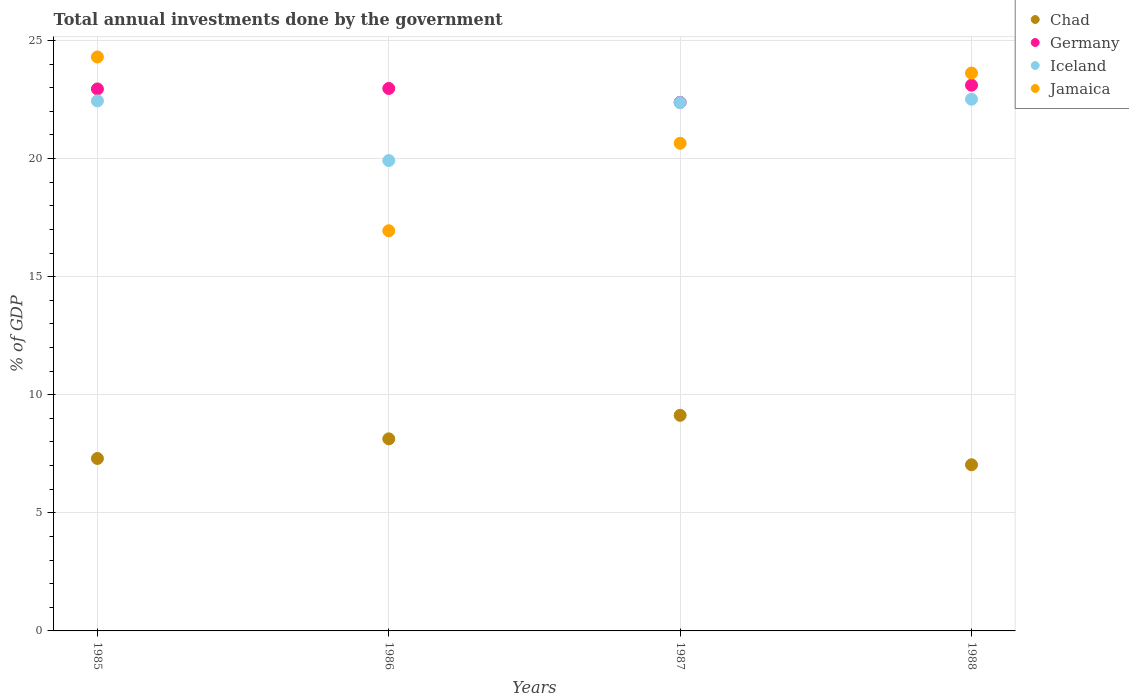What is the total annual investments done by the government in Iceland in 1987?
Your response must be concise. 22.37. Across all years, what is the maximum total annual investments done by the government in Germany?
Provide a short and direct response. 23.11. Across all years, what is the minimum total annual investments done by the government in Jamaica?
Offer a terse response. 16.94. In which year was the total annual investments done by the government in Germany minimum?
Offer a very short reply. 1987. What is the total total annual investments done by the government in Chad in the graph?
Give a very brief answer. 31.6. What is the difference between the total annual investments done by the government in Chad in 1985 and that in 1987?
Make the answer very short. -1.83. What is the difference between the total annual investments done by the government in Germany in 1988 and the total annual investments done by the government in Iceland in 1987?
Provide a short and direct response. 0.74. What is the average total annual investments done by the government in Germany per year?
Ensure brevity in your answer.  22.85. In the year 1985, what is the difference between the total annual investments done by the government in Germany and total annual investments done by the government in Jamaica?
Your answer should be very brief. -1.35. What is the ratio of the total annual investments done by the government in Chad in 1985 to that in 1986?
Your response must be concise. 0.9. What is the difference between the highest and the second highest total annual investments done by the government in Iceland?
Your response must be concise. 0.07. What is the difference between the highest and the lowest total annual investments done by the government in Jamaica?
Your answer should be very brief. 7.36. Is the sum of the total annual investments done by the government in Germany in 1986 and 1987 greater than the maximum total annual investments done by the government in Chad across all years?
Offer a very short reply. Yes. Does the total annual investments done by the government in Jamaica monotonically increase over the years?
Your answer should be compact. No. How many years are there in the graph?
Keep it short and to the point. 4. What is the difference between two consecutive major ticks on the Y-axis?
Provide a short and direct response. 5. Does the graph contain any zero values?
Provide a short and direct response. No. Where does the legend appear in the graph?
Offer a terse response. Top right. How many legend labels are there?
Provide a succinct answer. 4. What is the title of the graph?
Your response must be concise. Total annual investments done by the government. Does "Armenia" appear as one of the legend labels in the graph?
Make the answer very short. No. What is the label or title of the X-axis?
Give a very brief answer. Years. What is the label or title of the Y-axis?
Give a very brief answer. % of GDP. What is the % of GDP of Chad in 1985?
Ensure brevity in your answer.  7.3. What is the % of GDP of Germany in 1985?
Your answer should be compact. 22.95. What is the % of GDP in Iceland in 1985?
Offer a very short reply. 22.44. What is the % of GDP of Jamaica in 1985?
Ensure brevity in your answer.  24.3. What is the % of GDP of Chad in 1986?
Offer a terse response. 8.13. What is the % of GDP in Germany in 1986?
Offer a terse response. 22.97. What is the % of GDP in Iceland in 1986?
Your answer should be compact. 19.92. What is the % of GDP of Jamaica in 1986?
Provide a short and direct response. 16.94. What is the % of GDP of Chad in 1987?
Provide a short and direct response. 9.13. What is the % of GDP in Germany in 1987?
Your answer should be compact. 22.38. What is the % of GDP of Iceland in 1987?
Offer a terse response. 22.37. What is the % of GDP in Jamaica in 1987?
Keep it short and to the point. 20.65. What is the % of GDP in Chad in 1988?
Provide a short and direct response. 7.04. What is the % of GDP in Germany in 1988?
Offer a very short reply. 23.11. What is the % of GDP of Iceland in 1988?
Make the answer very short. 22.52. What is the % of GDP of Jamaica in 1988?
Give a very brief answer. 23.62. Across all years, what is the maximum % of GDP in Chad?
Ensure brevity in your answer.  9.13. Across all years, what is the maximum % of GDP in Germany?
Ensure brevity in your answer.  23.11. Across all years, what is the maximum % of GDP in Iceland?
Provide a short and direct response. 22.52. Across all years, what is the maximum % of GDP in Jamaica?
Offer a terse response. 24.3. Across all years, what is the minimum % of GDP in Chad?
Ensure brevity in your answer.  7.04. Across all years, what is the minimum % of GDP of Germany?
Your response must be concise. 22.38. Across all years, what is the minimum % of GDP of Iceland?
Offer a very short reply. 19.92. Across all years, what is the minimum % of GDP of Jamaica?
Ensure brevity in your answer.  16.94. What is the total % of GDP in Chad in the graph?
Ensure brevity in your answer.  31.6. What is the total % of GDP in Germany in the graph?
Ensure brevity in your answer.  91.41. What is the total % of GDP in Iceland in the graph?
Give a very brief answer. 87.25. What is the total % of GDP in Jamaica in the graph?
Offer a terse response. 85.52. What is the difference between the % of GDP of Chad in 1985 and that in 1986?
Keep it short and to the point. -0.83. What is the difference between the % of GDP in Germany in 1985 and that in 1986?
Your response must be concise. -0.02. What is the difference between the % of GDP in Iceland in 1985 and that in 1986?
Your answer should be compact. 2.53. What is the difference between the % of GDP of Jamaica in 1985 and that in 1986?
Give a very brief answer. 7.36. What is the difference between the % of GDP of Chad in 1985 and that in 1987?
Provide a succinct answer. -1.83. What is the difference between the % of GDP of Germany in 1985 and that in 1987?
Ensure brevity in your answer.  0.57. What is the difference between the % of GDP of Iceland in 1985 and that in 1987?
Give a very brief answer. 0.07. What is the difference between the % of GDP of Jamaica in 1985 and that in 1987?
Provide a succinct answer. 3.65. What is the difference between the % of GDP of Chad in 1985 and that in 1988?
Your answer should be compact. 0.27. What is the difference between the % of GDP of Germany in 1985 and that in 1988?
Make the answer very short. -0.16. What is the difference between the % of GDP of Iceland in 1985 and that in 1988?
Make the answer very short. -0.07. What is the difference between the % of GDP in Jamaica in 1985 and that in 1988?
Make the answer very short. 0.68. What is the difference between the % of GDP in Chad in 1986 and that in 1987?
Keep it short and to the point. -1. What is the difference between the % of GDP in Germany in 1986 and that in 1987?
Your answer should be compact. 0.59. What is the difference between the % of GDP in Iceland in 1986 and that in 1987?
Offer a very short reply. -2.46. What is the difference between the % of GDP in Jamaica in 1986 and that in 1987?
Your answer should be compact. -3.7. What is the difference between the % of GDP in Chad in 1986 and that in 1988?
Your answer should be compact. 1.1. What is the difference between the % of GDP of Germany in 1986 and that in 1988?
Your answer should be very brief. -0.14. What is the difference between the % of GDP of Iceland in 1986 and that in 1988?
Offer a very short reply. -2.6. What is the difference between the % of GDP in Jamaica in 1986 and that in 1988?
Provide a short and direct response. -6.68. What is the difference between the % of GDP in Chad in 1987 and that in 1988?
Your answer should be compact. 2.09. What is the difference between the % of GDP in Germany in 1987 and that in 1988?
Offer a very short reply. -0.73. What is the difference between the % of GDP of Iceland in 1987 and that in 1988?
Give a very brief answer. -0.14. What is the difference between the % of GDP of Jamaica in 1987 and that in 1988?
Offer a very short reply. -2.97. What is the difference between the % of GDP in Chad in 1985 and the % of GDP in Germany in 1986?
Provide a short and direct response. -15.67. What is the difference between the % of GDP in Chad in 1985 and the % of GDP in Iceland in 1986?
Offer a very short reply. -12.61. What is the difference between the % of GDP in Chad in 1985 and the % of GDP in Jamaica in 1986?
Offer a very short reply. -9.64. What is the difference between the % of GDP in Germany in 1985 and the % of GDP in Iceland in 1986?
Provide a succinct answer. 3.03. What is the difference between the % of GDP of Germany in 1985 and the % of GDP of Jamaica in 1986?
Your answer should be compact. 6.01. What is the difference between the % of GDP in Iceland in 1985 and the % of GDP in Jamaica in 1986?
Make the answer very short. 5.5. What is the difference between the % of GDP of Chad in 1985 and the % of GDP of Germany in 1987?
Provide a succinct answer. -15.08. What is the difference between the % of GDP in Chad in 1985 and the % of GDP in Iceland in 1987?
Keep it short and to the point. -15.07. What is the difference between the % of GDP of Chad in 1985 and the % of GDP of Jamaica in 1987?
Make the answer very short. -13.35. What is the difference between the % of GDP of Germany in 1985 and the % of GDP of Iceland in 1987?
Offer a very short reply. 0.58. What is the difference between the % of GDP in Germany in 1985 and the % of GDP in Jamaica in 1987?
Offer a very short reply. 2.3. What is the difference between the % of GDP of Iceland in 1985 and the % of GDP of Jamaica in 1987?
Your response must be concise. 1.79. What is the difference between the % of GDP in Chad in 1985 and the % of GDP in Germany in 1988?
Your response must be concise. -15.81. What is the difference between the % of GDP of Chad in 1985 and the % of GDP of Iceland in 1988?
Provide a succinct answer. -15.21. What is the difference between the % of GDP of Chad in 1985 and the % of GDP of Jamaica in 1988?
Your answer should be very brief. -16.32. What is the difference between the % of GDP in Germany in 1985 and the % of GDP in Iceland in 1988?
Offer a very short reply. 0.43. What is the difference between the % of GDP of Germany in 1985 and the % of GDP of Jamaica in 1988?
Your answer should be very brief. -0.67. What is the difference between the % of GDP of Iceland in 1985 and the % of GDP of Jamaica in 1988?
Your response must be concise. -1.18. What is the difference between the % of GDP in Chad in 1986 and the % of GDP in Germany in 1987?
Ensure brevity in your answer.  -14.25. What is the difference between the % of GDP in Chad in 1986 and the % of GDP in Iceland in 1987?
Offer a very short reply. -14.24. What is the difference between the % of GDP of Chad in 1986 and the % of GDP of Jamaica in 1987?
Your response must be concise. -12.52. What is the difference between the % of GDP of Germany in 1986 and the % of GDP of Iceland in 1987?
Ensure brevity in your answer.  0.6. What is the difference between the % of GDP of Germany in 1986 and the % of GDP of Jamaica in 1987?
Ensure brevity in your answer.  2.32. What is the difference between the % of GDP in Iceland in 1986 and the % of GDP in Jamaica in 1987?
Keep it short and to the point. -0.73. What is the difference between the % of GDP in Chad in 1986 and the % of GDP in Germany in 1988?
Keep it short and to the point. -14.98. What is the difference between the % of GDP of Chad in 1986 and the % of GDP of Iceland in 1988?
Give a very brief answer. -14.38. What is the difference between the % of GDP of Chad in 1986 and the % of GDP of Jamaica in 1988?
Provide a succinct answer. -15.49. What is the difference between the % of GDP in Germany in 1986 and the % of GDP in Iceland in 1988?
Your answer should be very brief. 0.45. What is the difference between the % of GDP in Germany in 1986 and the % of GDP in Jamaica in 1988?
Keep it short and to the point. -0.65. What is the difference between the % of GDP of Iceland in 1986 and the % of GDP of Jamaica in 1988?
Provide a short and direct response. -3.7. What is the difference between the % of GDP of Chad in 1987 and the % of GDP of Germany in 1988?
Make the answer very short. -13.98. What is the difference between the % of GDP of Chad in 1987 and the % of GDP of Iceland in 1988?
Ensure brevity in your answer.  -13.39. What is the difference between the % of GDP of Chad in 1987 and the % of GDP of Jamaica in 1988?
Provide a succinct answer. -14.49. What is the difference between the % of GDP in Germany in 1987 and the % of GDP in Iceland in 1988?
Offer a very short reply. -0.13. What is the difference between the % of GDP in Germany in 1987 and the % of GDP in Jamaica in 1988?
Your answer should be very brief. -1.24. What is the difference between the % of GDP in Iceland in 1987 and the % of GDP in Jamaica in 1988?
Keep it short and to the point. -1.25. What is the average % of GDP in Chad per year?
Ensure brevity in your answer.  7.9. What is the average % of GDP of Germany per year?
Your answer should be compact. 22.85. What is the average % of GDP in Iceland per year?
Offer a very short reply. 21.81. What is the average % of GDP in Jamaica per year?
Your answer should be compact. 21.38. In the year 1985, what is the difference between the % of GDP of Chad and % of GDP of Germany?
Give a very brief answer. -15.65. In the year 1985, what is the difference between the % of GDP in Chad and % of GDP in Iceland?
Keep it short and to the point. -15.14. In the year 1985, what is the difference between the % of GDP of Chad and % of GDP of Jamaica?
Offer a very short reply. -17. In the year 1985, what is the difference between the % of GDP of Germany and % of GDP of Iceland?
Your answer should be very brief. 0.51. In the year 1985, what is the difference between the % of GDP in Germany and % of GDP in Jamaica?
Your response must be concise. -1.35. In the year 1985, what is the difference between the % of GDP in Iceland and % of GDP in Jamaica?
Provide a succinct answer. -1.86. In the year 1986, what is the difference between the % of GDP in Chad and % of GDP in Germany?
Give a very brief answer. -14.84. In the year 1986, what is the difference between the % of GDP of Chad and % of GDP of Iceland?
Provide a short and direct response. -11.78. In the year 1986, what is the difference between the % of GDP of Chad and % of GDP of Jamaica?
Your answer should be compact. -8.81. In the year 1986, what is the difference between the % of GDP of Germany and % of GDP of Iceland?
Ensure brevity in your answer.  3.05. In the year 1986, what is the difference between the % of GDP in Germany and % of GDP in Jamaica?
Offer a very short reply. 6.03. In the year 1986, what is the difference between the % of GDP in Iceland and % of GDP in Jamaica?
Ensure brevity in your answer.  2.97. In the year 1987, what is the difference between the % of GDP in Chad and % of GDP in Germany?
Ensure brevity in your answer.  -13.25. In the year 1987, what is the difference between the % of GDP in Chad and % of GDP in Iceland?
Give a very brief answer. -13.24. In the year 1987, what is the difference between the % of GDP in Chad and % of GDP in Jamaica?
Provide a succinct answer. -11.52. In the year 1987, what is the difference between the % of GDP in Germany and % of GDP in Iceland?
Offer a terse response. 0.01. In the year 1987, what is the difference between the % of GDP of Germany and % of GDP of Jamaica?
Offer a terse response. 1.73. In the year 1987, what is the difference between the % of GDP in Iceland and % of GDP in Jamaica?
Ensure brevity in your answer.  1.72. In the year 1988, what is the difference between the % of GDP of Chad and % of GDP of Germany?
Your response must be concise. -16.07. In the year 1988, what is the difference between the % of GDP of Chad and % of GDP of Iceland?
Keep it short and to the point. -15.48. In the year 1988, what is the difference between the % of GDP in Chad and % of GDP in Jamaica?
Keep it short and to the point. -16.59. In the year 1988, what is the difference between the % of GDP in Germany and % of GDP in Iceland?
Provide a short and direct response. 0.59. In the year 1988, what is the difference between the % of GDP in Germany and % of GDP in Jamaica?
Ensure brevity in your answer.  -0.51. In the year 1988, what is the difference between the % of GDP of Iceland and % of GDP of Jamaica?
Your answer should be compact. -1.11. What is the ratio of the % of GDP in Chad in 1985 to that in 1986?
Offer a terse response. 0.9. What is the ratio of the % of GDP of Germany in 1985 to that in 1986?
Offer a terse response. 1. What is the ratio of the % of GDP in Iceland in 1985 to that in 1986?
Offer a terse response. 1.13. What is the ratio of the % of GDP of Jamaica in 1985 to that in 1986?
Ensure brevity in your answer.  1.43. What is the ratio of the % of GDP of Chad in 1985 to that in 1987?
Keep it short and to the point. 0.8. What is the ratio of the % of GDP in Germany in 1985 to that in 1987?
Your answer should be very brief. 1.03. What is the ratio of the % of GDP of Jamaica in 1985 to that in 1987?
Make the answer very short. 1.18. What is the ratio of the % of GDP of Chad in 1985 to that in 1988?
Provide a short and direct response. 1.04. What is the ratio of the % of GDP in Jamaica in 1985 to that in 1988?
Ensure brevity in your answer.  1.03. What is the ratio of the % of GDP of Chad in 1986 to that in 1987?
Provide a succinct answer. 0.89. What is the ratio of the % of GDP of Germany in 1986 to that in 1987?
Offer a terse response. 1.03. What is the ratio of the % of GDP of Iceland in 1986 to that in 1987?
Provide a succinct answer. 0.89. What is the ratio of the % of GDP of Jamaica in 1986 to that in 1987?
Give a very brief answer. 0.82. What is the ratio of the % of GDP of Chad in 1986 to that in 1988?
Your answer should be compact. 1.16. What is the ratio of the % of GDP in Iceland in 1986 to that in 1988?
Offer a terse response. 0.88. What is the ratio of the % of GDP in Jamaica in 1986 to that in 1988?
Provide a succinct answer. 0.72. What is the ratio of the % of GDP of Chad in 1987 to that in 1988?
Make the answer very short. 1.3. What is the ratio of the % of GDP of Germany in 1987 to that in 1988?
Keep it short and to the point. 0.97. What is the ratio of the % of GDP in Iceland in 1987 to that in 1988?
Ensure brevity in your answer.  0.99. What is the ratio of the % of GDP in Jamaica in 1987 to that in 1988?
Your answer should be compact. 0.87. What is the difference between the highest and the second highest % of GDP in Germany?
Your answer should be very brief. 0.14. What is the difference between the highest and the second highest % of GDP of Iceland?
Keep it short and to the point. 0.07. What is the difference between the highest and the second highest % of GDP in Jamaica?
Provide a short and direct response. 0.68. What is the difference between the highest and the lowest % of GDP of Chad?
Offer a very short reply. 2.09. What is the difference between the highest and the lowest % of GDP of Germany?
Your answer should be very brief. 0.73. What is the difference between the highest and the lowest % of GDP of Iceland?
Your answer should be compact. 2.6. What is the difference between the highest and the lowest % of GDP in Jamaica?
Keep it short and to the point. 7.36. 